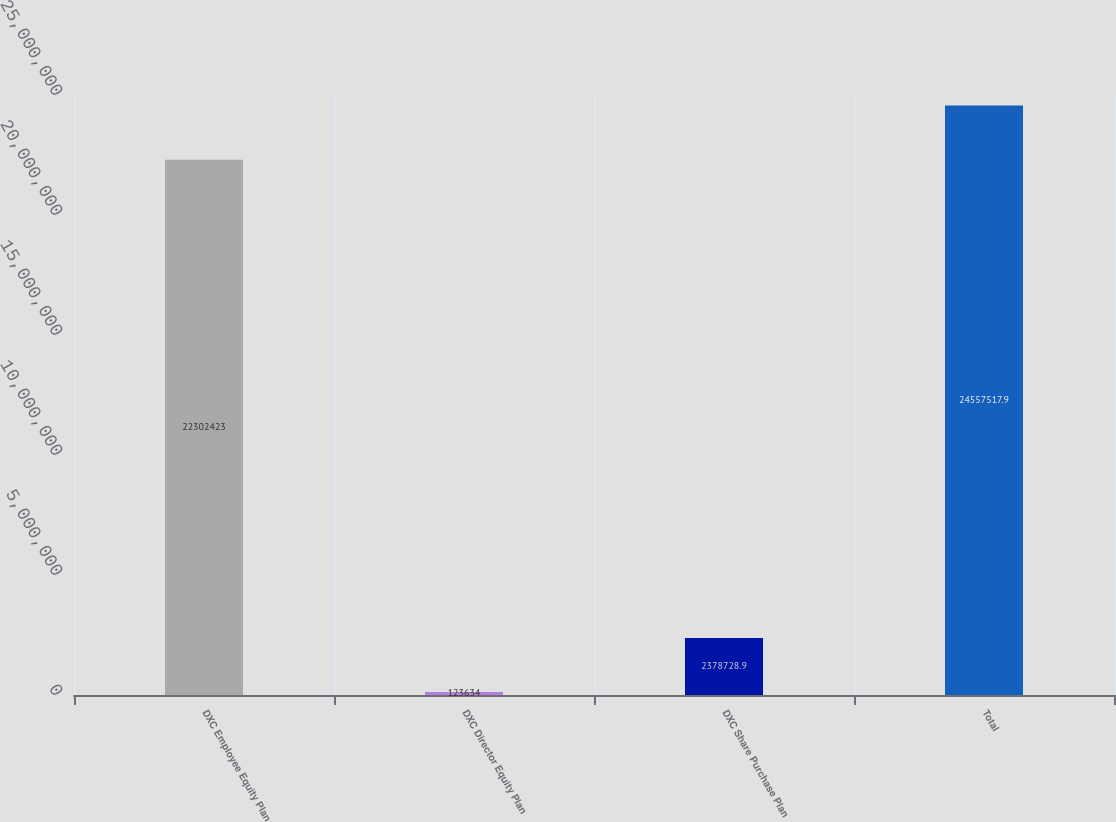Convert chart. <chart><loc_0><loc_0><loc_500><loc_500><bar_chart><fcel>DXC Employee Equity Plan<fcel>DXC Director Equity Plan<fcel>DXC Share Purchase Plan<fcel>Total<nl><fcel>2.23024e+07<fcel>123634<fcel>2.37873e+06<fcel>2.45575e+07<nl></chart> 